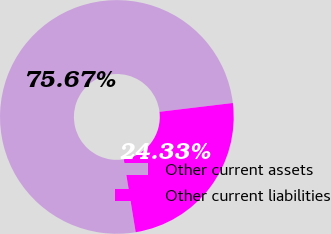<chart> <loc_0><loc_0><loc_500><loc_500><pie_chart><fcel>Other current assets<fcel>Other current liabilities<nl><fcel>75.67%<fcel>24.33%<nl></chart> 